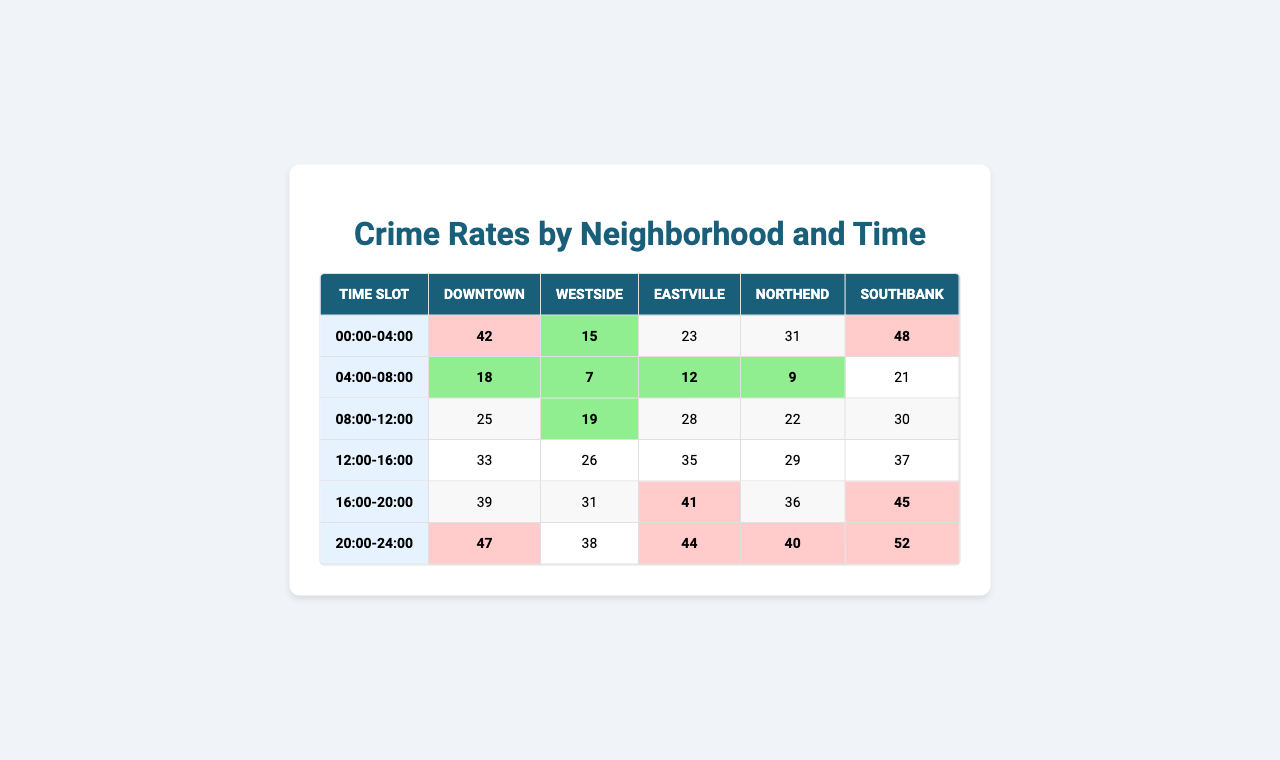What is the highest crime rate recorded in Downtown? Looking at the Downtown row, the highest crime rate listed is 48, which occurs between the time slots 16:00-20:00.
Answer: 48 Which neighborhood has the lowest crime rate in the 04:00-08:00 time slot? The 04:00-08:00 time slot shows crime rates of 15 for Downtown, 7 for Westside, 19 for Eastville, 26 for Northend, and 31 for Southbank. The lowest is 7 in the Westside.
Answer: Westside What is the average crime rate for Eastville over all time slots? The crime rates for Eastville are 25, 19, 28, 22, and 30. Adding these yields 25 + 19 + 28 + 22 + 30 = 124. Dividing by the number of time slots (5) gives an average of 124/5 = 24.8.
Answer: 24.8 Is the crime rate in Northend during the 12:00-16:00 time slot higher than that in Southbank during the same time slot? The crime rate in Northend for the 12:00-16:00 slot is 29, while in Southbank it is 36. Since 29 is less than 36, the answer is no.
Answer: No Which time slot has the highest total crime rate across all neighborhoods? Summing up each column for each time slot: 00:00-04:00 yields 42+18+25+33+39=157, 04:00-08:00 gives 15+7+19+26+31=98, 08:00-12:00 equals 23+12+28+35+41=139, 12:00-16:00 is 31+9+22+29+36=127, 16:00-20:00 totals 48+21+30+37+45=181, and 20:00-24:00 totals 47+38+44+40+52=221. The highest is 221 in the 20:00-24:00 slot.
Answer: 20:00-24:00 How many time slots have a crime rate of 40 or above in Northend? Inspecting Northend's rates: 33, 26, 35, 29, and 37, only the rate 35 is 40 or above. Therefore, there is only one time slot that meets this condition.
Answer: 1 What is the difference in crime rates between the highest and lowest rates in Southbank? Southbank's crime rates are 39, 31, 41, 36, and 45. The highest is 45 and the lowest is 31. Therefore, the difference is 45 - 31 = 14.
Answer: 14 Does Downtown have more high-crime time slots (rates 40 or above) than Westside? Downtown has rates of 42, 15, 23, 31, and 48, which includes 42 and 48, totaling 2 high-crime slots. Westside's rates are 18, 7, 12, 9, and 21, none are 40 or above, totaling 0. Since 2 > 0, the answer is yes.
Answer: Yes What are the total crime rates for all neighborhoods during the 08:00-12:00 time slot? Adding the crime rates for this time slot: 23 (Downtown) + 12 (Westside) + 28 (Eastville) + 35 (Northend) + 41 (Southbank) equals 23 + 12 + 28 + 35 + 41 = 139.
Answer: 139 Which neighborhood has the highest crime rate during the 00:00-04:00 time slot? Checking the rates: Downtown has 42, Westside has 18, Eastville has 25, Northend has 33, and Southbank has 39. The highest is 42 in Downtown.
Answer: Downtown 